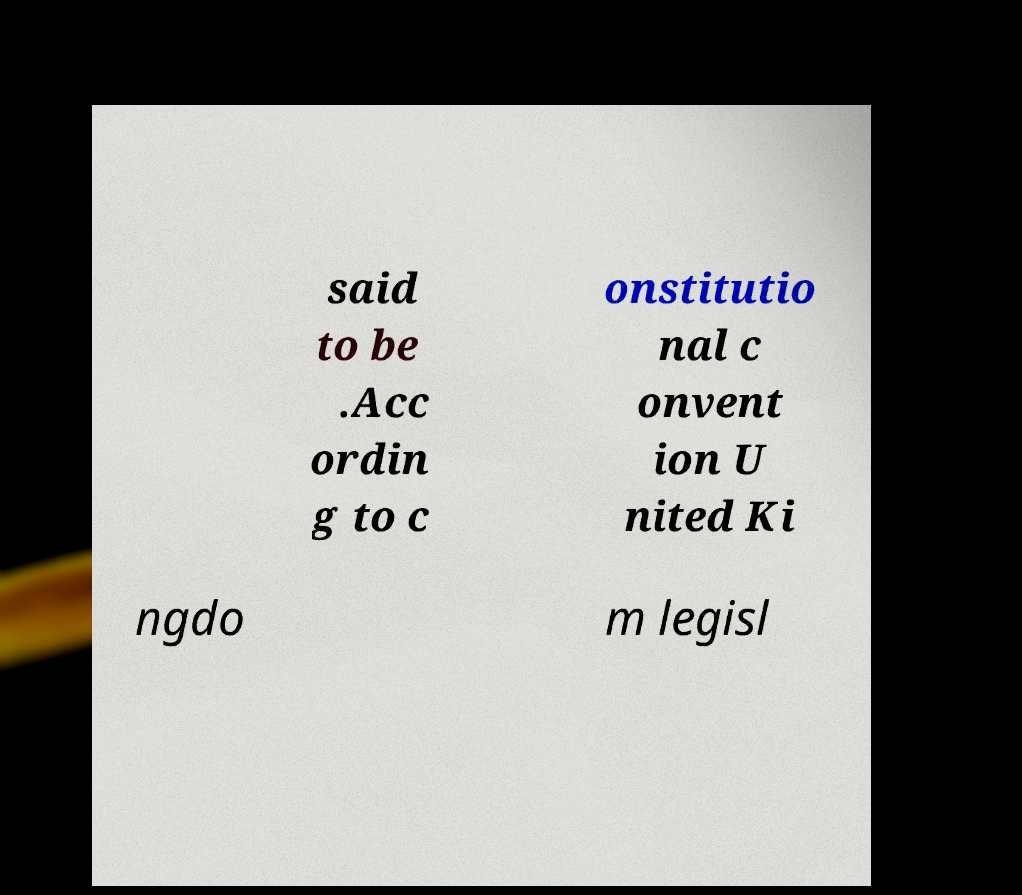Please read and relay the text visible in this image. What does it say? said to be .Acc ordin g to c onstitutio nal c onvent ion U nited Ki ngdo m legisl 